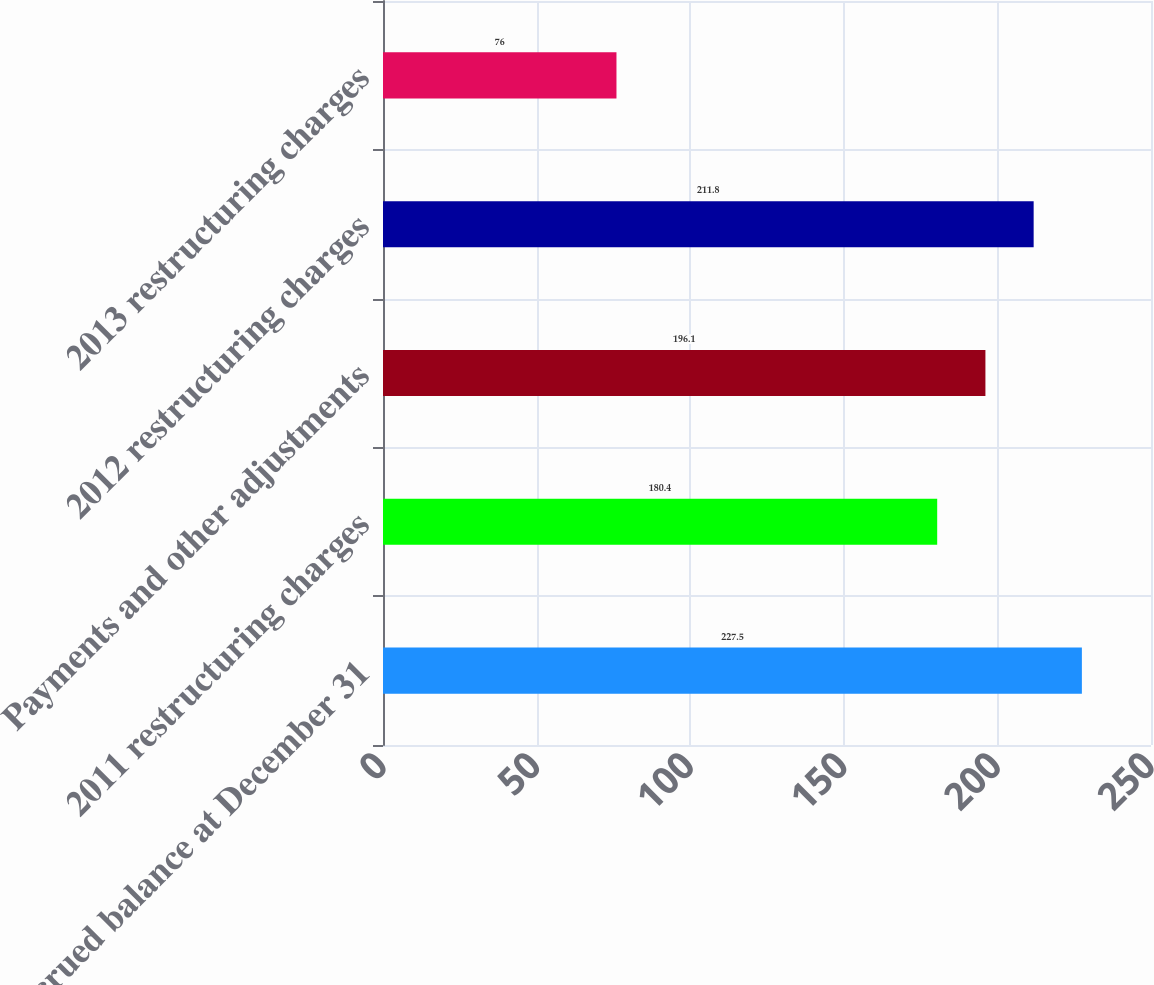Convert chart to OTSL. <chart><loc_0><loc_0><loc_500><loc_500><bar_chart><fcel>Accrued balance at December 31<fcel>2011 restructuring charges<fcel>Payments and other adjustments<fcel>2012 restructuring charges<fcel>2013 restructuring charges<nl><fcel>227.5<fcel>180.4<fcel>196.1<fcel>211.8<fcel>76<nl></chart> 